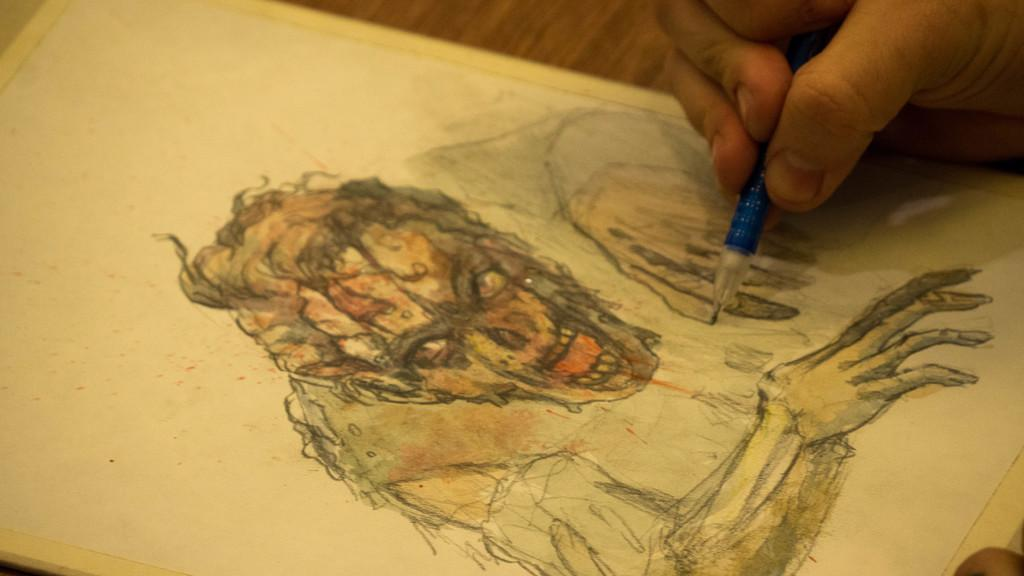What is depicted on the paper in the image? There is a drawing on a paper in the image. Who is holding the pencil in the image? There is a person holding a pencil in the image. What type of oatmeal is being exchanged between the women in the image? There are no women or oatmeal present in the image; it only features a drawing on a paper and a person holding a pencil. 